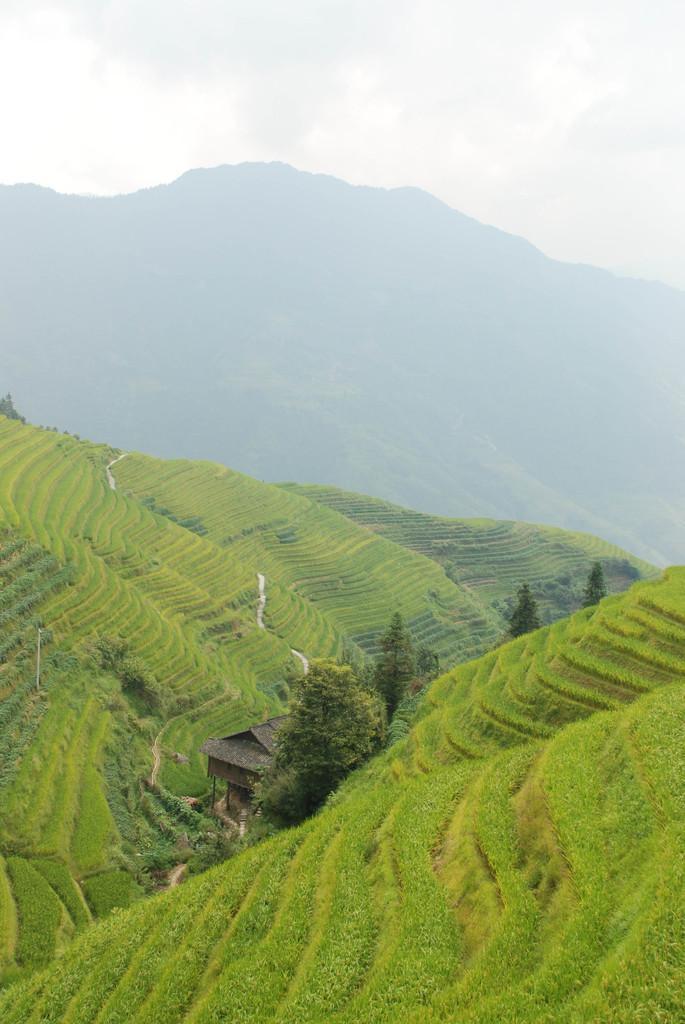Can you describe this image briefly? In the picture we can see hills covered with grass and in the middle of the hills we can see some trees and a small house and in the background we can see some hills and the sky with clouds. 